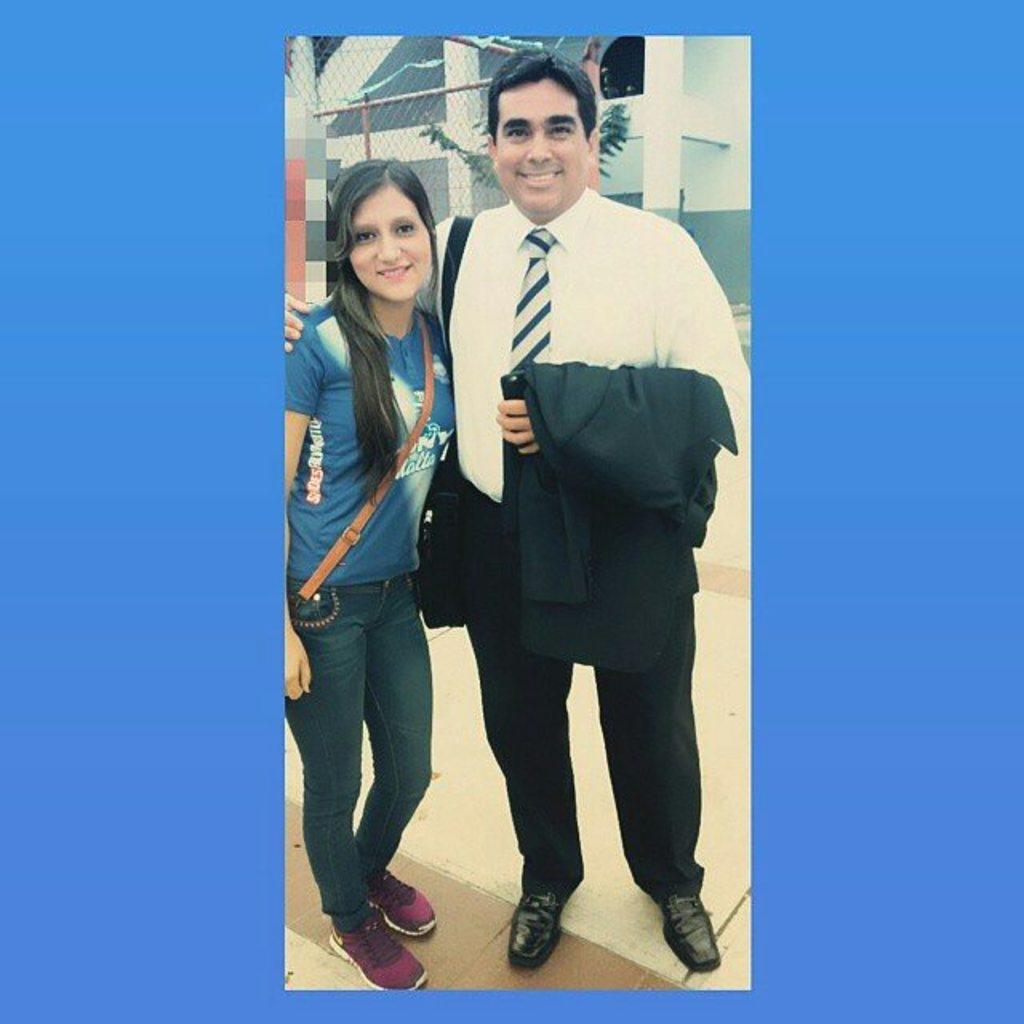How many people are present in the image? There are two people, a man and a woman, present in the image. What are the man and the woman doing in the image? Both the man and the woman are standing on the floor and smiling. What can be seen in the background of the image? There is a building in the background of the image. Is there any barrier or structure visible in the image? Yes, there is a fence visible in the image. What type of pen is the actor using to write in the image? There is no actor or pen present in the image; it features a man and a woman standing near a fence with a building in the background. 